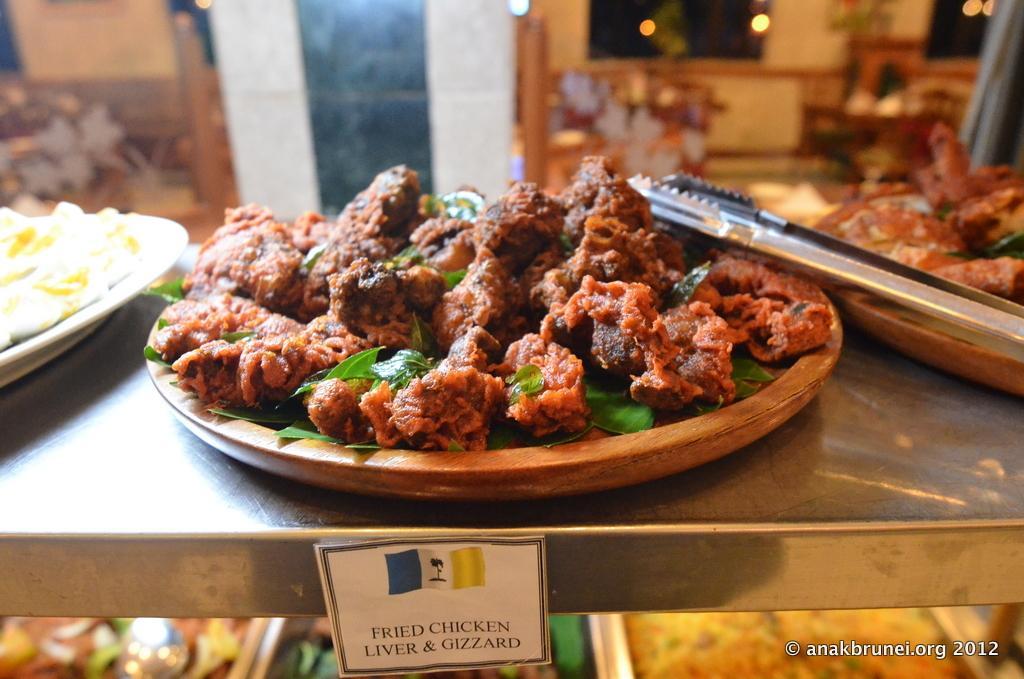Describe this image in one or two sentences. Here I can see three plates are placed on a table. These three plates consists of some food items. Under the table there are some more food items. At the bottom of this image I can see a white color paper which is attached to the table. On this paper I can see some text. In the background, I can see the wall, windows and chairs. 